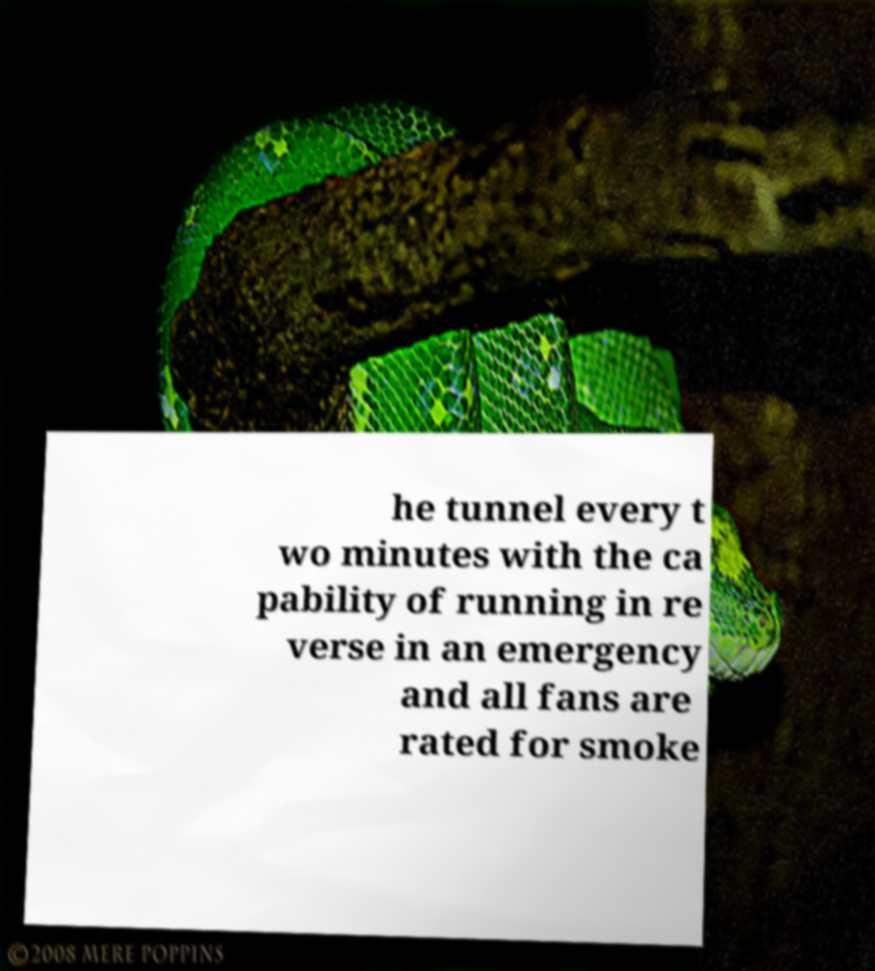Can you accurately transcribe the text from the provided image for me? he tunnel every t wo minutes with the ca pability of running in re verse in an emergency and all fans are rated for smoke 